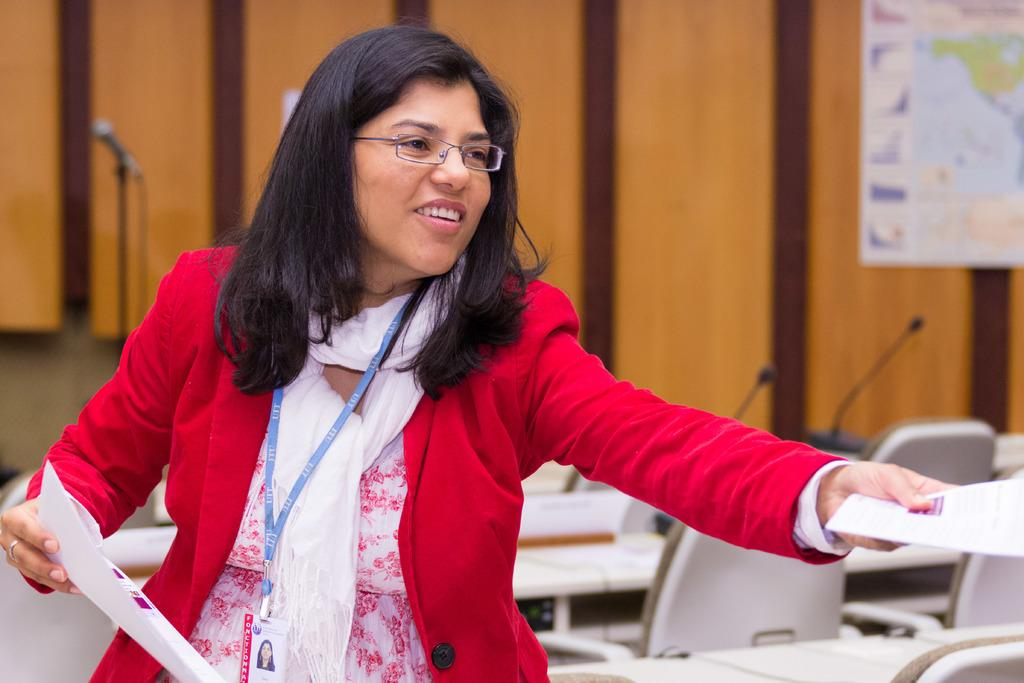What is the person in the image holding? The person is holding papers in the image. What type of furniture can be seen in the image? There are chairs visible in the image. What animals are present in the image? There are mice in the image. What is on the table in the image? There are objects on a table in the image. What is attached to the wall in the image? There is a board attached to a brown-colored wall in the image. What type of whistle is the person using to communicate with the men in the image? There is no whistle or men present in the image; it only features a person holding papers, chairs, mice, objects on a table, and a board attached to a brown-colored wall. 